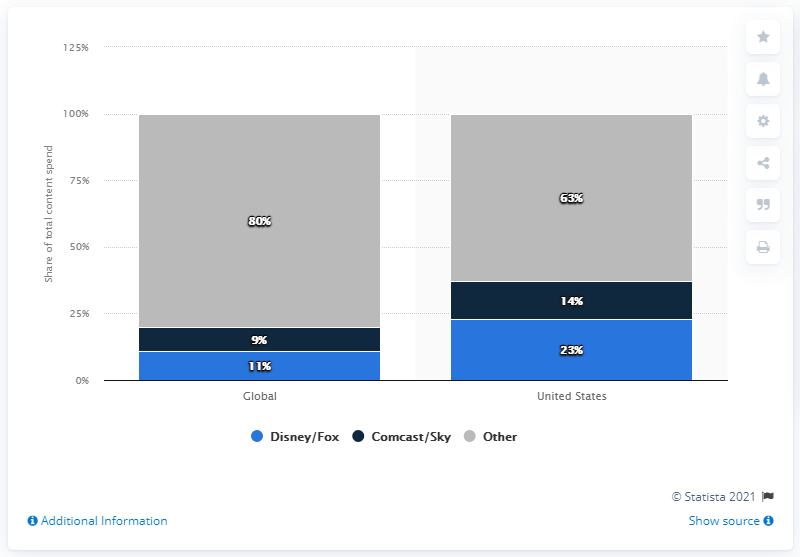List a handful of essential elements in this visual. According to sources, Disney/Fox is estimated to have commanded a significant portion of the total content spend in the U.S. market, approximately 23%. 